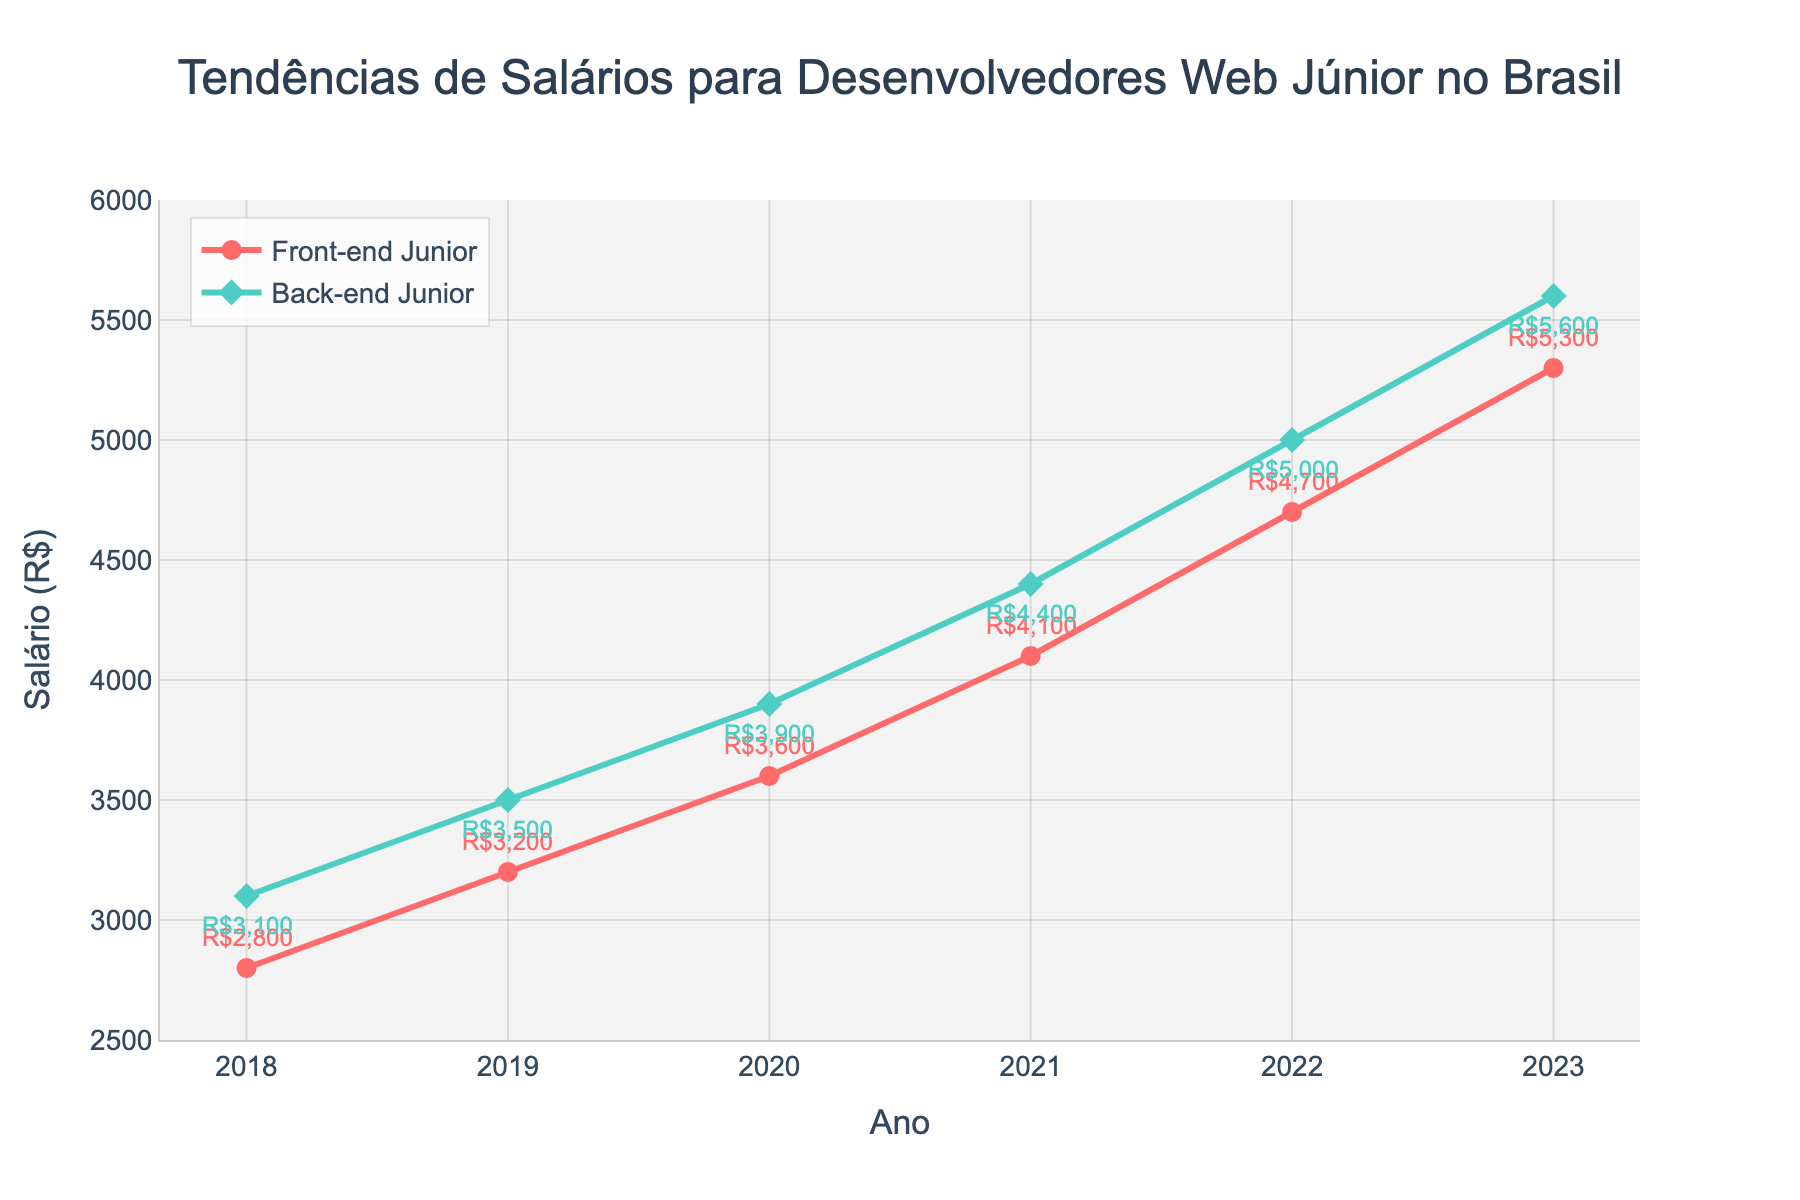Qual foi o maior aumento percentual no salário dos desenvolvedores Front-end Júnior entre dois anos consecutivos? Para descobrir o maior aumento percentual, precisamos calcular a mudança percentual para cada par consecutivo de anos e comparar os resultados. Aumento de 2019: (3200 - 2800) / 2800 * 100 = 14.29%, aumento de 2020: (3600 - 3200) / 3200 * 100 = 12.50%, aumento de 2021: (4100 - 3600) / 3600 * 100 = 13.89%, aumento de 2022: (4700 - 4100) / 4100 * 100 = 14.63%, aumento de 2023: (5300 - 4700) / 4700 * 100 = 12.77%. O maior aumento percentual foi de 14.63% entre 2021 e 2022.
Answer: 14.63% Quais anos mostraram uma diferença salarial maior de R$ 500 entre desenvolvedores Front-end Júnior e Back-end Júnior? Precisamos subtrair os salários dos desenvolvedores Front-end Júnior dos Back-end Júnior para cada ano e verificar se a diferença é maior que R$ 500. 2018: 3100 - 2800 = 300, 2019: 3500 - 3200 = 300, 2020: 3900 - 3600 = 300, 2021: 4400 - 4100 = 300, 2022: 5000 - 4700 = 300, 2023: 5600 - 5300 = 300. Nenhum ano teve uma diferença salarial superior a R$ 500.
Answer: Nenhum ano Qual foi a razão entre os salários dos desenvolvedores Back-end Júnior e Front-end Júnior em 2023? A razão é encontrada dividindo o salário dos desenvolvedores Back-end Júnior pelo dos Front-end Júnior em 2023. Salário Back-end: R$ 5600, salário Front-end: R$ 5300. Razão: 5600 / 5300 ≈ 1.06.
Answer: 1.06 Quais anos tiveram a menor diferença percentual entre os salários dos desenvolvedores Front-end Júnior e Back-end Júnior? Para calcular a menor diferença percentual, precisamos calcular a diferença percentual para cada par de anos e identificar o menor valor. Diferença percentual de 2018: (3100 - 2800) / 3100 * 100 ≈ 9.68%, 2019: (3500 - 3200) / 3500 * 100 ≈ 8.57%, 2020: (3900 - 3600) / 3900 * 100 ≈ 7.69%, 2021: (4400 - 4100) / 4400 * 100 ≈ 6.82%, 2022: (5000 - 4700) / 5000 * 100 ≈ 6.00%, 2023: (5600 - 5300) / 5600 * 100 ≈ 5.36%. O menor valor é em 2023 com 5.36%.
Answer: 2023 Em que ano os desenvolvedores Front-end Júnior viram um aumento superior a R$ 500 em seu salário em relação ao ano anterior? Precisamos verificar a diferença de salário de um ano para o seguinte e ver onde a diferença é maior que R$ 500. Diferença de 2019: 3200 - 2800 = 400, diferença de 2020: 3600 - 3200 = 400, diferença de 2021: 4100 - 3600 = 500, diferença de 2022: 4700 - 4100 = 600, diferença de 2023: 5300 - 4700 = 600. Os aumentos superiores a R$ 500 foram em 2022 e 2023.
Answer: 2022 e 2023 O que era maior em 2019, o salário dos desenvolvedores Front-end Júnior ou o salário dos desenvolvedores Back-end Júnior em 2018? Comparando o salário dos desenvolvedores Front-end Júnior em 2019 (R$ 3200) com o dos desenvolvedores Back-end Júnior em 2018 (R$ 3100), podemos ver que R$ 3200 é maior que R$ 3100.
Answer: Front-end Júnior em 2019 Qual foi o aumento total nos salários dos desenvolvedores Back-end Júnior de 2018 a 2023? Devemos subtrair o salário inicial em 2018 (R$ 3100) do salário final em 2023 (R$ 5600) para obter o aumento total. 5600 - 3100 = 2500.
Answer: R$ 2500 